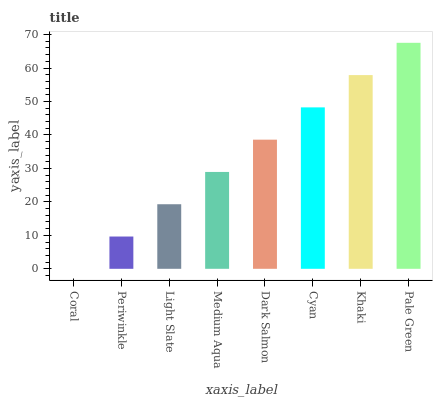Is Coral the minimum?
Answer yes or no. Yes. Is Pale Green the maximum?
Answer yes or no. Yes. Is Periwinkle the minimum?
Answer yes or no. No. Is Periwinkle the maximum?
Answer yes or no. No. Is Periwinkle greater than Coral?
Answer yes or no. Yes. Is Coral less than Periwinkle?
Answer yes or no. Yes. Is Coral greater than Periwinkle?
Answer yes or no. No. Is Periwinkle less than Coral?
Answer yes or no. No. Is Dark Salmon the high median?
Answer yes or no. Yes. Is Medium Aqua the low median?
Answer yes or no. Yes. Is Pale Green the high median?
Answer yes or no. No. Is Khaki the low median?
Answer yes or no. No. 